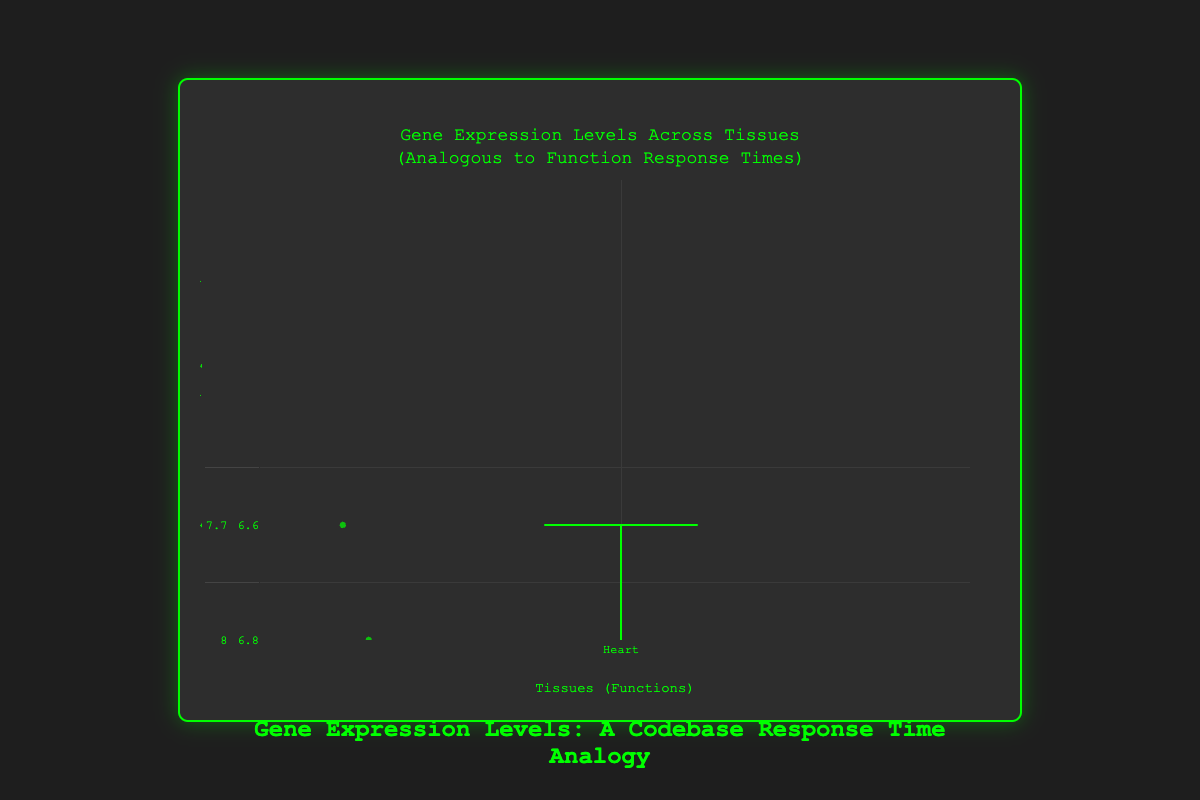Which tissue has the highest median expression level? The highest median expression level can be determined by looking at the box plot and identifying the tissue with the highest median line. In the box plot, Brain has the highest median expression level as its median line is higher than those of the other tissues.
Answer: Brain Which tissue shows the widest range of expression levels? The range of expression levels is indicated by the distance between the minimum and maximum values (whiskers) in the box plot. The tissue with the widest range is Brain as it has the greatest distance between the whiskers' endpoints.
Answer: Brain Which tissue has the lowest expression levels overall? The lowest expression levels overall can be identified by looking at the tissue with the lowest bottom whisker in the box plot. Lung has the lowest overall expression levels since its bottom whisker is the lowest.
Answer: Lung What is the median expression level of the Liver tissue? The median expression level is represented by the line inside the box. For the Liver tissue, the median is at 6.8.
Answer: 6.8 How do the median expression levels of Heart and Kidney compare? To compare the medians, observe the lines inside each respective box. The median expression level for Heart is around 7.9 whereas for Kidney it is around 7.0, so Heart has a higher median expression level than Kidney.
Answer: Heart has a higher median Which tissue has the most consistent expression levels? Consistency can be evaluated by looking at the shortest range between the whiskers’ endpoints in the box plot. The Lung tissue shows the most consistent levels as its box and whiskers are the shortest, indicating less variability.
Answer: Lung Are there any outliers in the data? Outliers are normally indicated by points that lie outside the whiskers in a box plot. There are no outliers visible in the box plot as there are no points outside the whiskers.
Answer: No How does the interquartile range (IQR) of Brain compare to that of Lung? The IQR is the distance between the first quartile (Q1) and the third quartile (Q3). For Brain, the IQR is large whereas for Lung, it is small. This indicates that the Brain has a wider spread in the middle 50% of its data compared to Lung.
Answer: Brain has a larger IQR What can we infer about the variability of gene expression levels in the Heart tissue? Variability can be assessed by the length of the box and whiskers. Heart shows moderate variability, with a relatively stretched box and whiskers, suggesting moderate spread in expression levels.
Answer: Moderate variability 